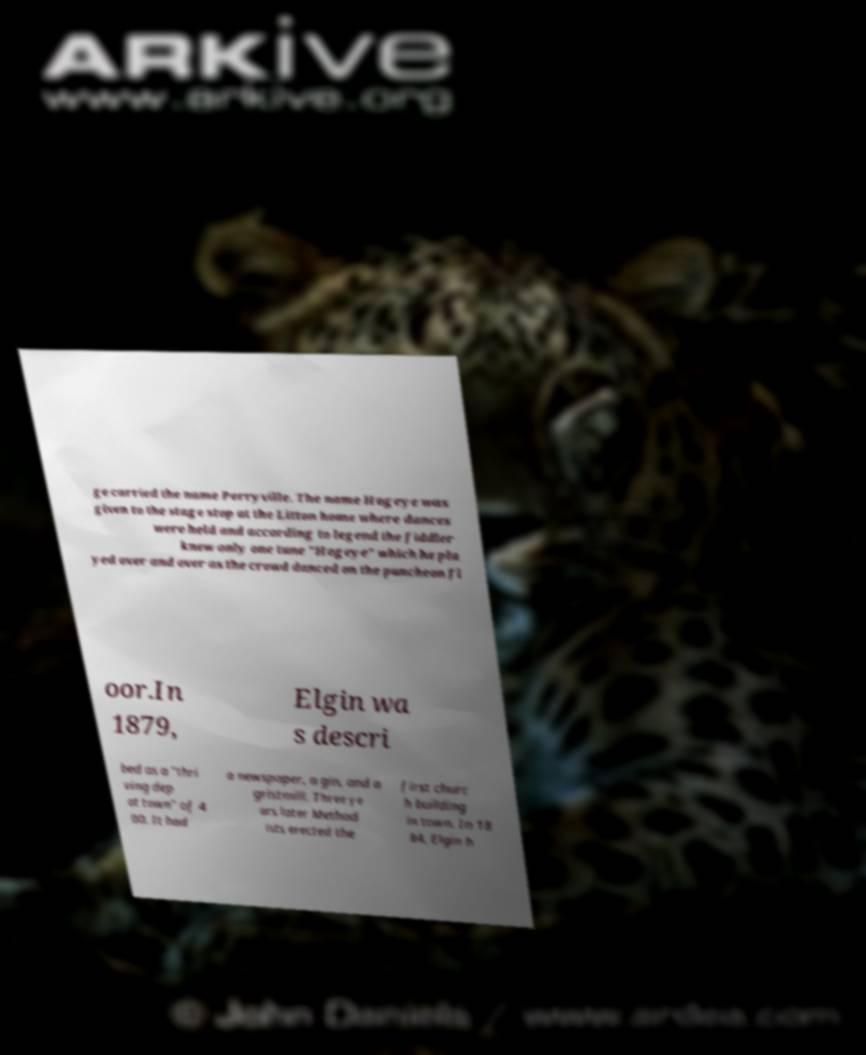Can you read and provide the text displayed in the image?This photo seems to have some interesting text. Can you extract and type it out for me? ge carried the name Perryville. The name Hogeye was given to the stage stop at the Litton home where dances were held and according to legend the fiddler knew only one tune "Hogeye" which he pla yed over and over as the crowd danced on the puncheon fl oor.In 1879, Elgin wa s descri bed as a "thri ving dep ot town" of 4 00. It had a newspaper, a gin, and a gristmill. Three ye ars later Method ists erected the first churc h building in town. In 18 84, Elgin h 